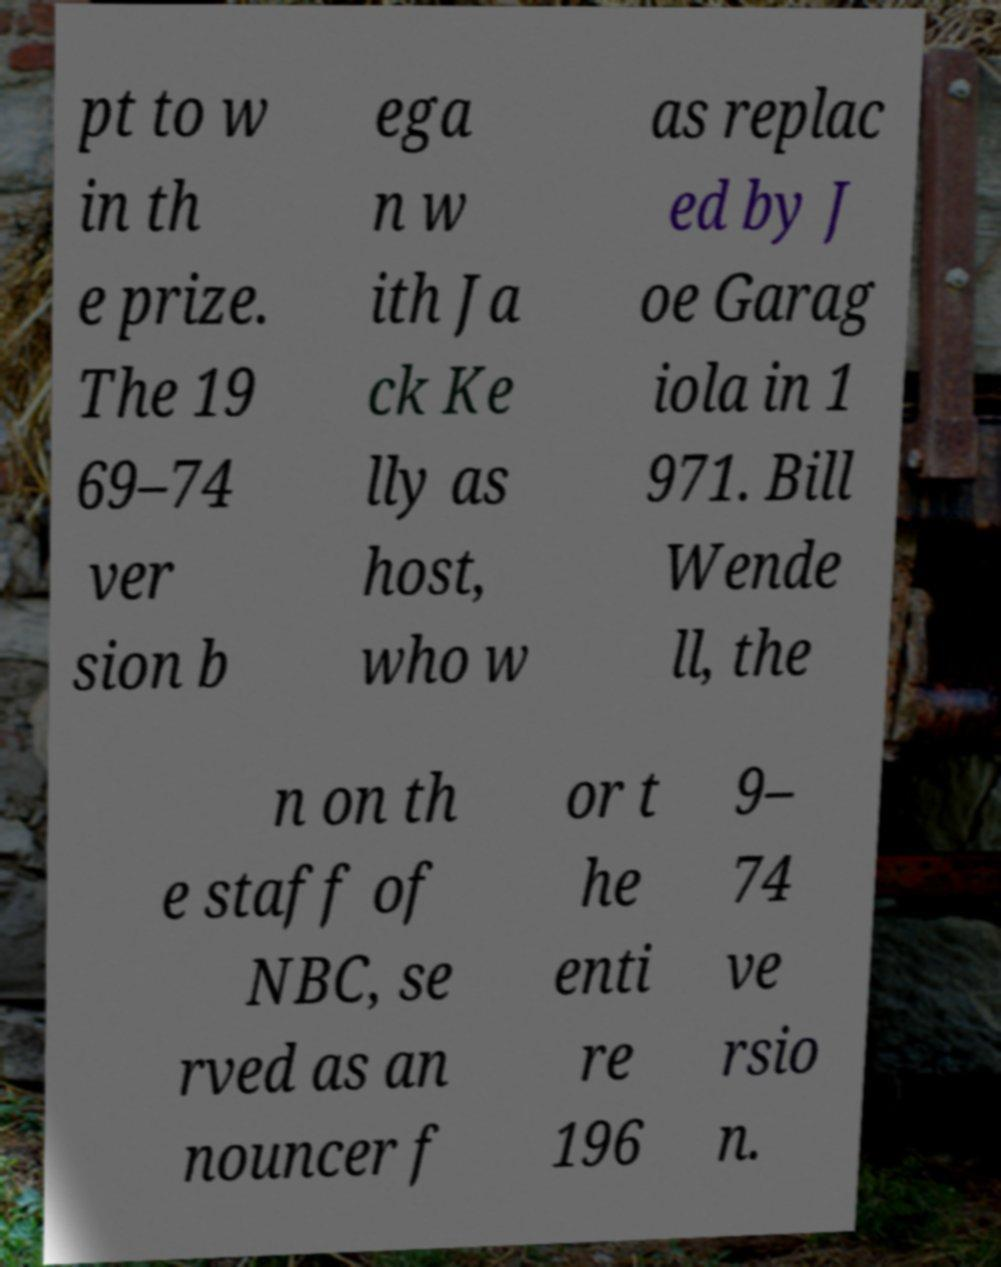There's text embedded in this image that I need extracted. Can you transcribe it verbatim? pt to w in th e prize. The 19 69–74 ver sion b ega n w ith Ja ck Ke lly as host, who w as replac ed by J oe Garag iola in 1 971. Bill Wende ll, the n on th e staff of NBC, se rved as an nouncer f or t he enti re 196 9– 74 ve rsio n. 